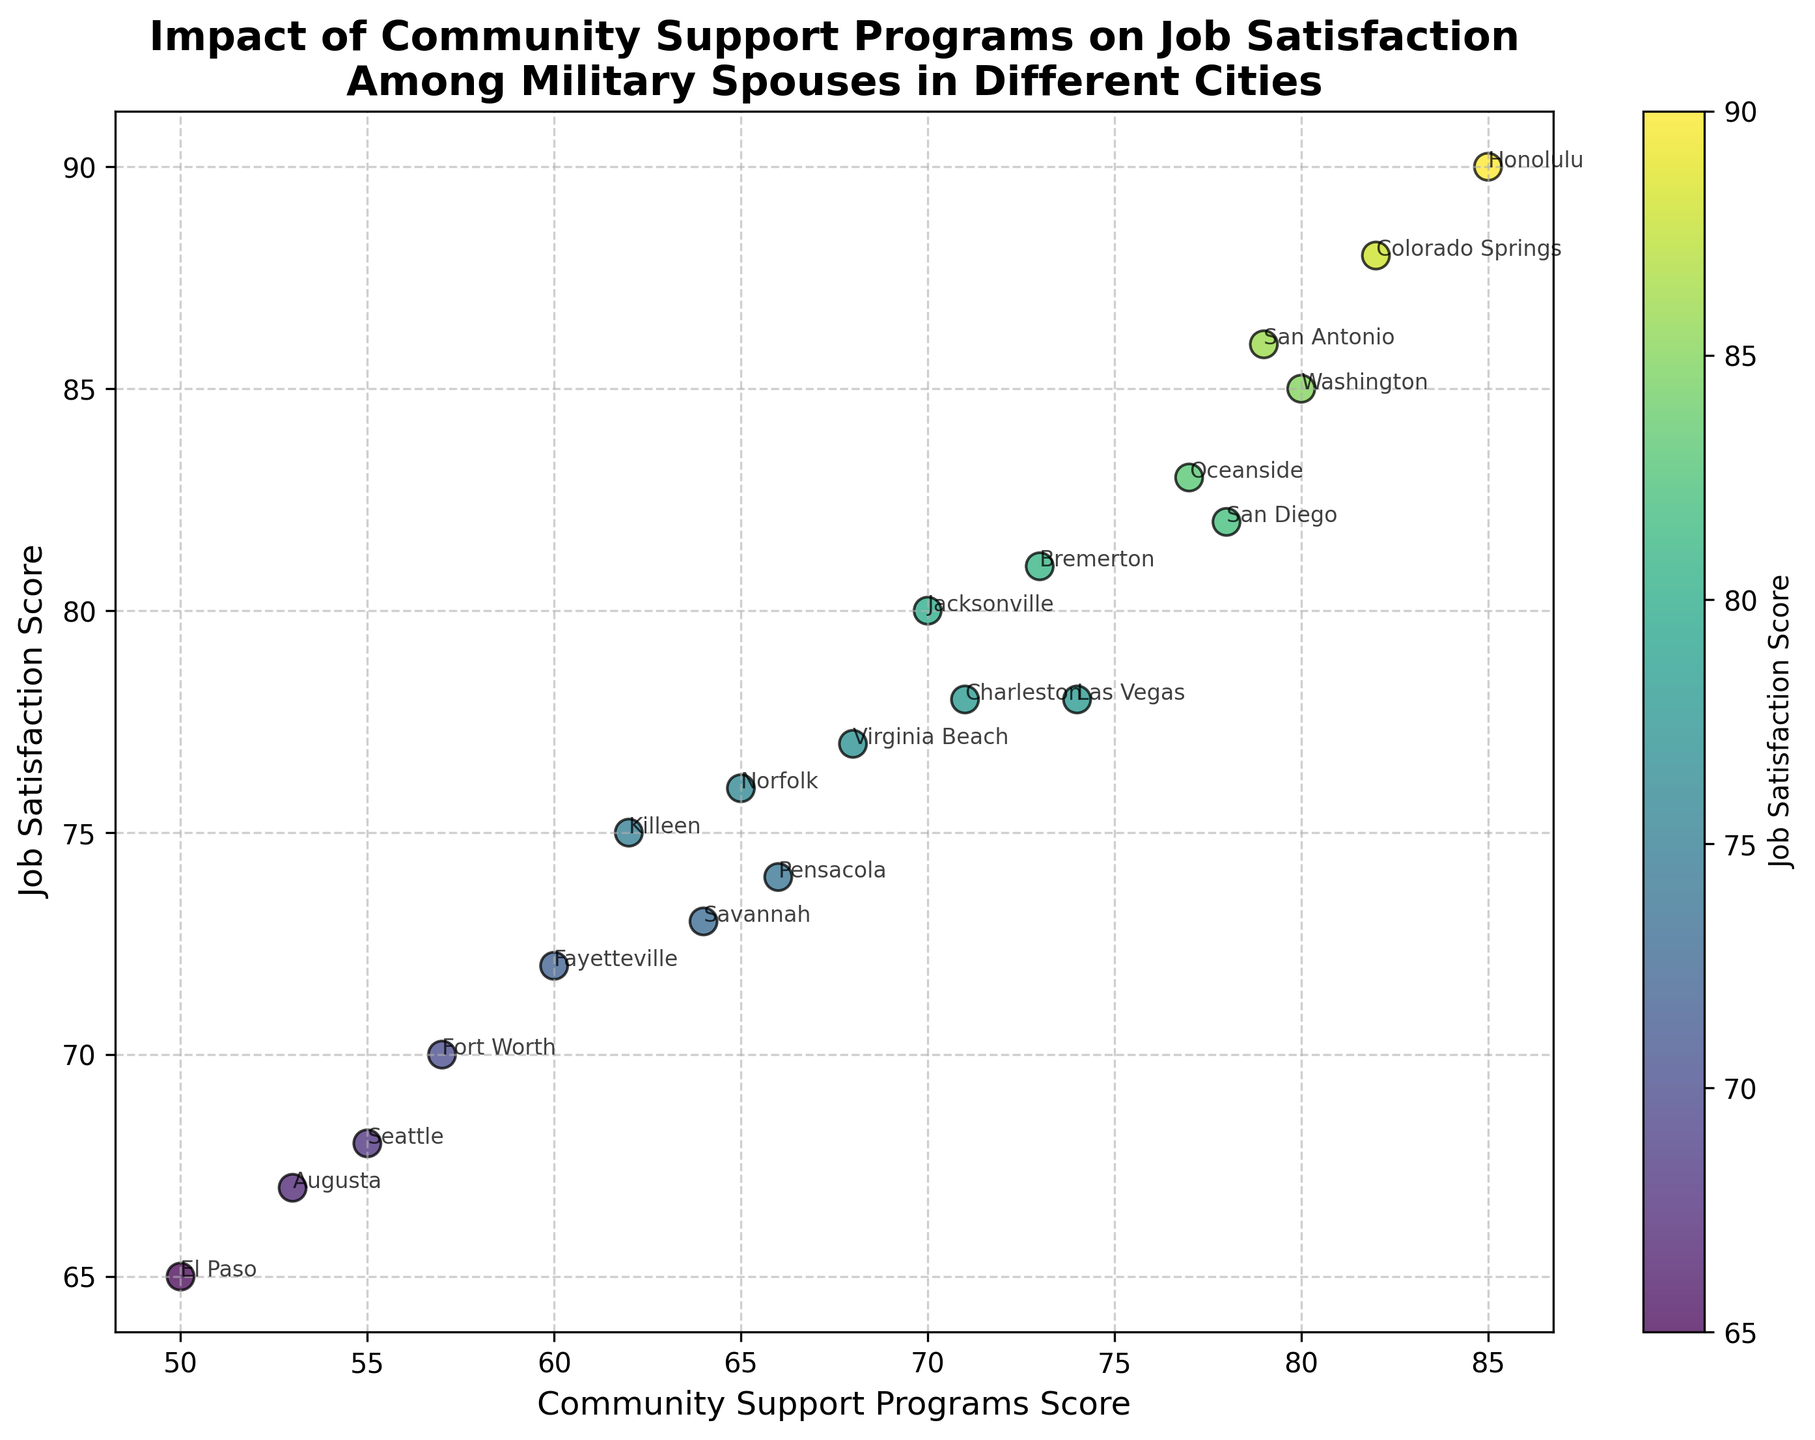Which city has the highest Job Satisfaction Score? By observing the scatter plot, we can see that the city which has the highest point on the y-axis represents the highest Job Satisfaction Score. The city at the topmost position is Honolulu.
Answer: Honolulu How does the Job Satisfaction Score in Jacksonville compare to Norfolk? Locate Jacksonville and Norfolk on the plot. Jacksonville has a Job Satisfaction Score of 80, while Norfolk has a score of 76. Comparing these, Jacksonville's score is higher.
Answer: Jacksonville is higher What is the average Community Support Programs Score for San Diego, Seattle, and Fayetteville? Find the Community Support Programs Scores for San Diego (78), Seattle (55), and Fayetteville (60). Add them together and divide by 3: (78 + 55 + 60) / 3.
Answer: 64.3 Which city has the lowest Community Support Programs Score? The lowest point on the x-axis represents the lowest Community Support Programs Score. The city at this position is El Paso.
Answer: El Paso Is there a general trend between Community Support Programs Score and Job Satisfaction Score? Observing the scatter plot, there is an apparent positive trend as higher Community Support Programs Scores generally correspond to higher Job Satisfaction Scores.
Answer: Yes, a positive trend Of the cities with a Job Satisfaction Score of 80 or higher, which one has the highest Community Support Programs Score? Identify cities with a Job Satisfaction Score of 80 or higher. Among San Diego, Jacksonville, Colorado Springs, Honolulu, Washington, Oceanside, San Antonio; Honolulu has the highest Community Support Programs Score of 85.
Answer: Honolulu What is the difference in Job Satisfaction Score between Colorado Springs and Killeen? Look at the Job Satisfaction Scores for Colorado Springs (88) and Killeen (75). Subtract Killeen's score from Colorado Springs': 88 - 75.
Answer: 13 Do cities with Community Support Programs Scores above 70 all have Job Satisfaction Scores higher than 75? Check the points corresponding to Community Support Programs Scores above 70, see if their Job Satisfaction Scores are all above 75. All cities like San Diego, Jacksonville, Colorado Springs, Honolulu, Washington, Oceanside, Las Vegas, Bremerton, San Antonio, and Charleston confirm this.
Answer: Yes What is the median Job Satisfaction Score of all cities on the scatter plot? Arrange the Job Satisfaction Scores (82, 76, 80, 68, 88, 72, 90, 85, 78, 65, 83, 70, 75, 77, 67, 74, 81, 86, 73, 78) in ascending order, find the middle value(s). The ordered scores are: 65, 67, 68, 70, 72, 73, 74, 75, 76, 77, 78, 78, 80, 81, 82, 83, 85, 86, 88, 90. Median is average of 10th and 11th values: (77+78)/2.
Answer: 77.5 